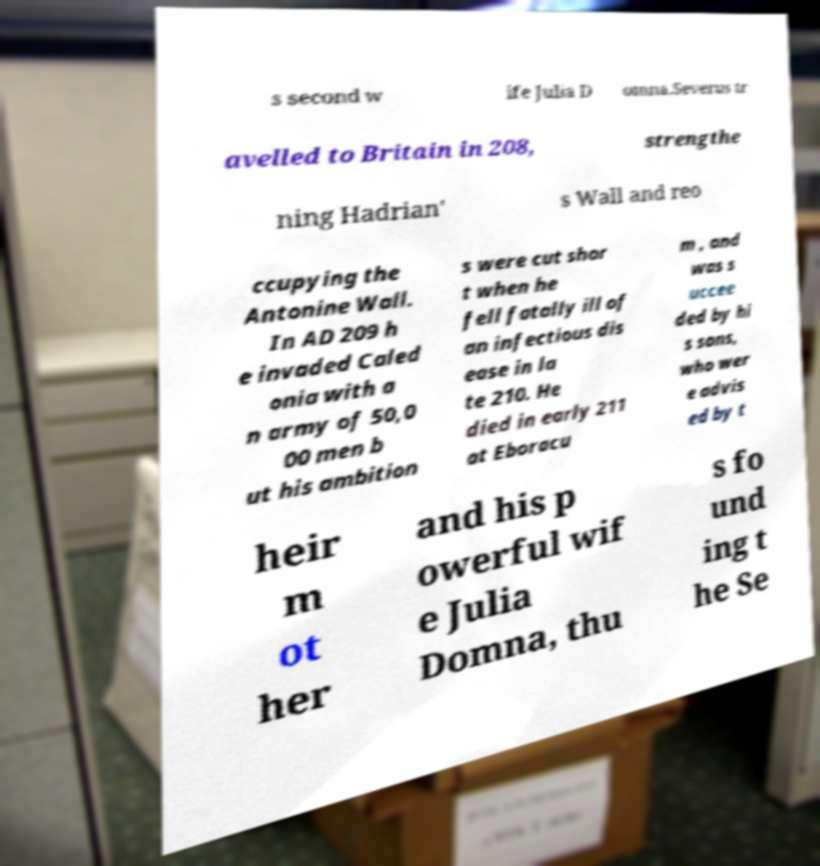Can you read and provide the text displayed in the image?This photo seems to have some interesting text. Can you extract and type it out for me? s second w ife Julia D omna.Severus tr avelled to Britain in 208, strengthe ning Hadrian' s Wall and reo ccupying the Antonine Wall. In AD 209 h e invaded Caled onia with a n army of 50,0 00 men b ut his ambition s were cut shor t when he fell fatally ill of an infectious dis ease in la te 210. He died in early 211 at Eboracu m , and was s uccee ded by hi s sons, who wer e advis ed by t heir m ot her and his p owerful wif e Julia Domna, thu s fo und ing t he Se 